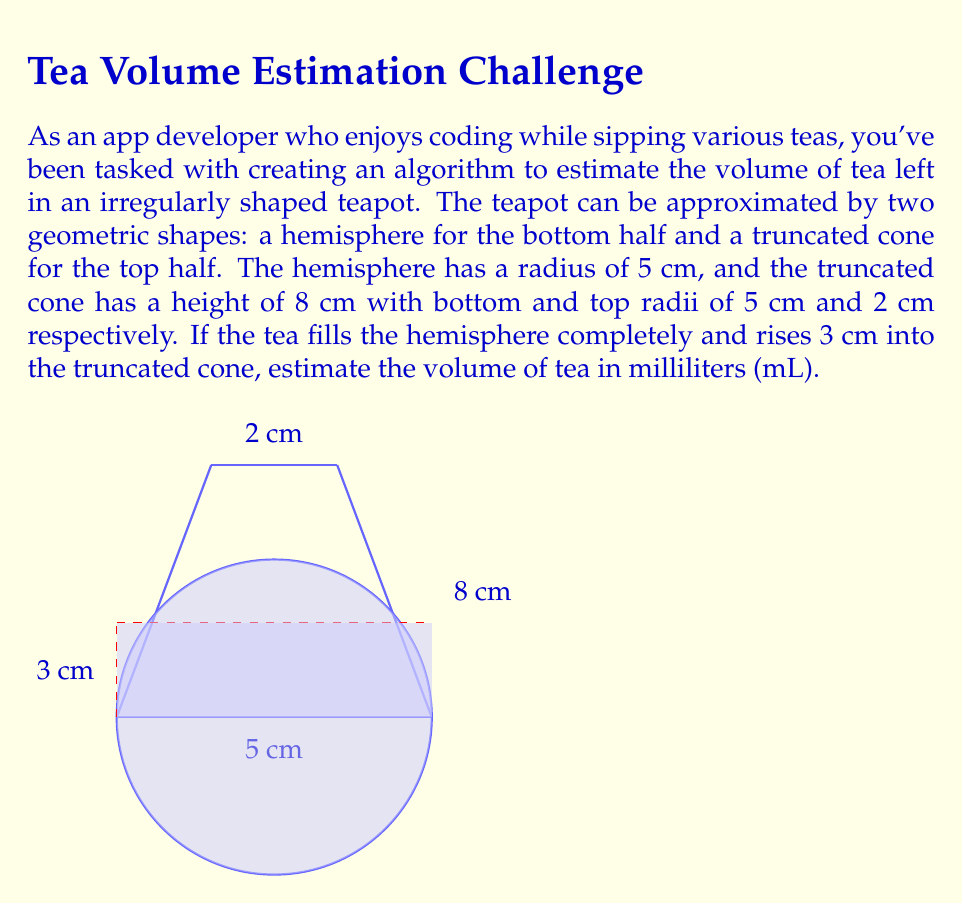Give your solution to this math problem. Let's break this problem down into steps:

1) First, calculate the volume of the hemisphere:
   $$V_{hemisphere} = \frac{2}{3}\pi r^3 = \frac{2}{3}\pi (5\text{ cm})^3 = \frac{250\pi}{3} \text{ cm}^3$$

2) Next, we need to calculate the volume of the tea in the truncated cone. We can use the formula for the volume of a truncated cone and adjust it for the partial height:
   $$V_{truncated\_cone} = \frac{1}{3}\pi h (R^2 + r^2 + Rr)$$
   where $h$ is the height, $R$ is the radius of the base, and $r$ is the radius of the top.

3) To find the radius at the tea level, we can use similar triangles:
   $$\frac{r-2}{5-2} = \frac{3}{8}$$
   $$r-2 = \frac{9}{8}$$
   $$r = \frac{25}{8} \text{ cm}$$

4) Now we can calculate the volume of tea in the truncated cone:
   $$V_{cone\_part} = \frac{1}{3}\pi (3\text{ cm}) ((5\text{ cm})^2 + (\frac{25}{8}\text{ cm})^2 + 5\text{ cm} \cdot \frac{25}{8}\text{ cm})$$
   $$= \pi (1\text{ cm}) (25 + \frac{625}{64} + \frac{125}{8}) \text{ cm}^2$$
   $$= \pi (25 + \frac{625}{64} + \frac{125}{8}) \text{ cm}^3$$

5) The total volume is the sum of these two parts:
   $$V_{total} = \frac{250\pi}{3} \text{ cm}^3 + \pi (25 + \frac{625}{64} + \frac{125}{8}) \text{ cm}^3$$
   $$= \pi (\frac{250}{3} + 25 + \frac{625}{64} + \frac{125}{8}) \text{ cm}^3$$
   $$\approx 368.65 \text{ cm}^3$$

6) Convert to milliliters:
   1 cm³ = 1 mL, so the volume is approximately 368.65 mL.
Answer: 368.65 mL 